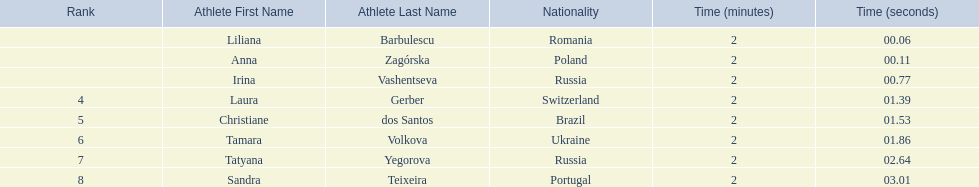Who came in second place at the athletics at the 2003 summer universiade - women's 800 metres? Anna Zagórska. What was her time? 2:00.11. 